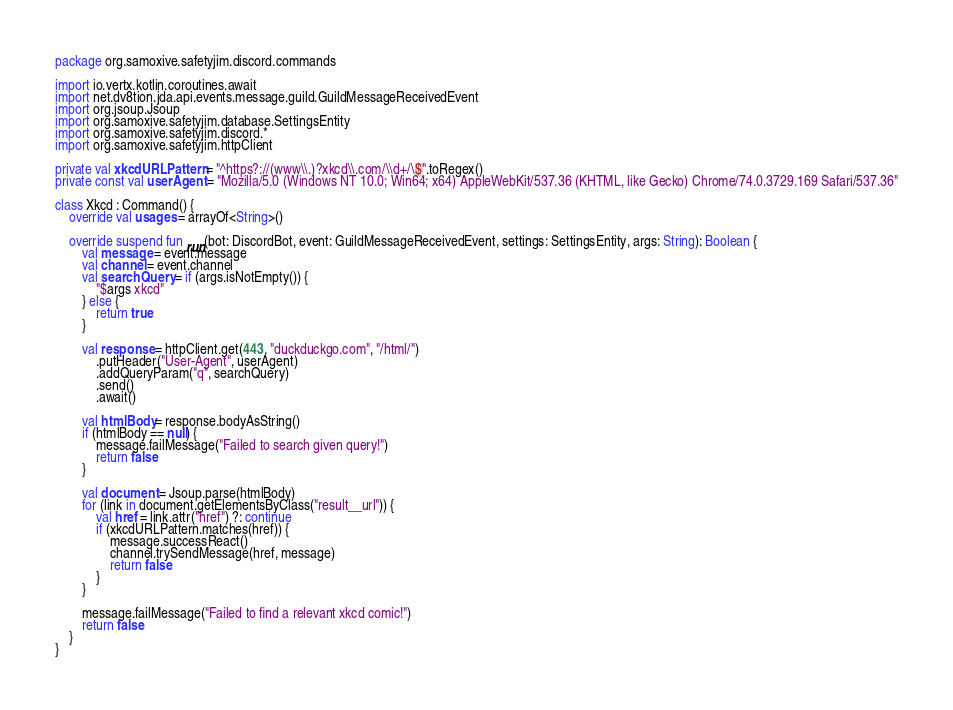Convert code to text. <code><loc_0><loc_0><loc_500><loc_500><_Kotlin_>package org.samoxive.safetyjim.discord.commands

import io.vertx.kotlin.coroutines.await
import net.dv8tion.jda.api.events.message.guild.GuildMessageReceivedEvent
import org.jsoup.Jsoup
import org.samoxive.safetyjim.database.SettingsEntity
import org.samoxive.safetyjim.discord.*
import org.samoxive.safetyjim.httpClient

private val xkcdURLPattern = "^https?://(www\\.)?xkcd\\.com/\\d+/\$".toRegex()
private const val userAgent = "Mozilla/5.0 (Windows NT 10.0; Win64; x64) AppleWebKit/537.36 (KHTML, like Gecko) Chrome/74.0.3729.169 Safari/537.36"

class Xkcd : Command() {
    override val usages = arrayOf<String>()

    override suspend fun run(bot: DiscordBot, event: GuildMessageReceivedEvent, settings: SettingsEntity, args: String): Boolean {
        val message = event.message
        val channel = event.channel
        val searchQuery = if (args.isNotEmpty()) {
            "$args xkcd"
        } else {
            return true
        }

        val response = httpClient.get(443, "duckduckgo.com", "/html/")
            .putHeader("User-Agent", userAgent)
            .addQueryParam("q", searchQuery)
            .send()
            .await()

        val htmlBody = response.bodyAsString()
        if (htmlBody == null) {
            message.failMessage("Failed to search given query!")
            return false
        }

        val document = Jsoup.parse(htmlBody)
        for (link in document.getElementsByClass("result__url")) {
            val href = link.attr("href") ?: continue
            if (xkcdURLPattern.matches(href)) {
                message.successReact()
                channel.trySendMessage(href, message)
                return false
            }
        }

        message.failMessage("Failed to find a relevant xkcd comic!")
        return false
    }
}
</code> 